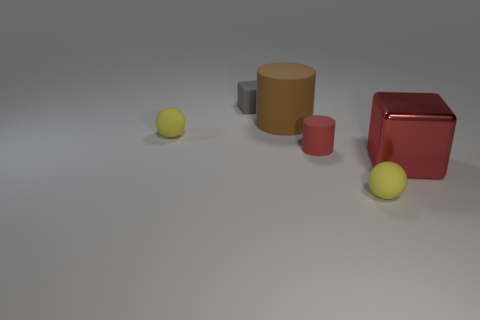Add 2 small blue balls. How many objects exist? 8 Subtract 2 cubes. How many cubes are left? 0 Subtract all cylinders. How many objects are left? 4 Subtract all brown balls. Subtract all yellow blocks. How many balls are left? 2 Subtract all big red objects. Subtract all metallic blocks. How many objects are left? 4 Add 6 rubber blocks. How many rubber blocks are left? 7 Add 2 blue blocks. How many blue blocks exist? 2 Subtract 0 purple cylinders. How many objects are left? 6 